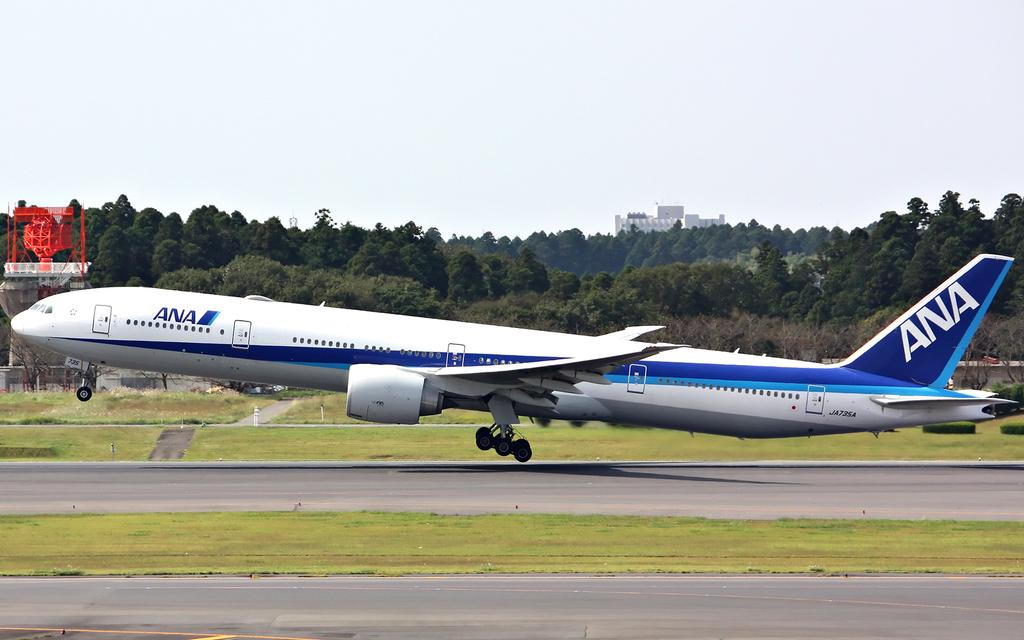<image>
Write a terse but informative summary of the picture. the word ana is on the back of a plane 